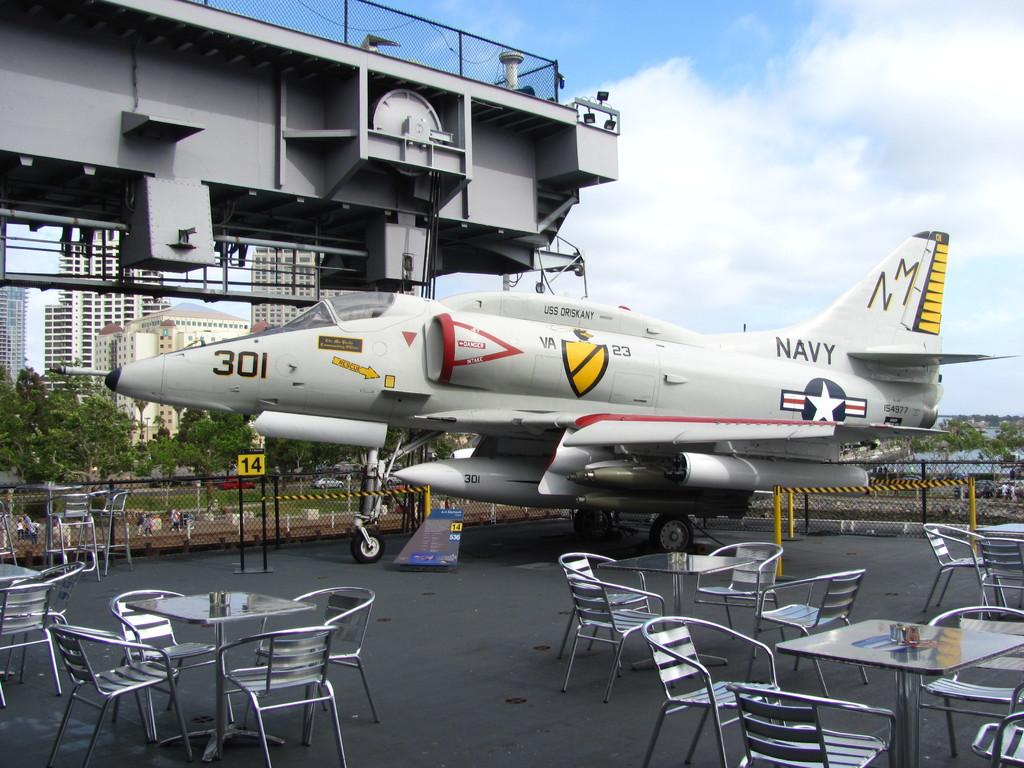What can be seen in the background of the image? There is an airplane, a table, a building, and trees in the background of the image. Can you describe the setting of the image based on the background? The background suggests that the image might have been taken in an area with a mix of natural and man-made elements, such as a park or urban setting. How many distinct structures or objects are visible in the background? There are four distinct structures or objects visible in the background: an airplane, a table, a building, and trees. Where is the vase located in the image? There is no vase present in the image. What type of furniture can be seen in the yard in the image? There is no yard or furniture present in the image. 